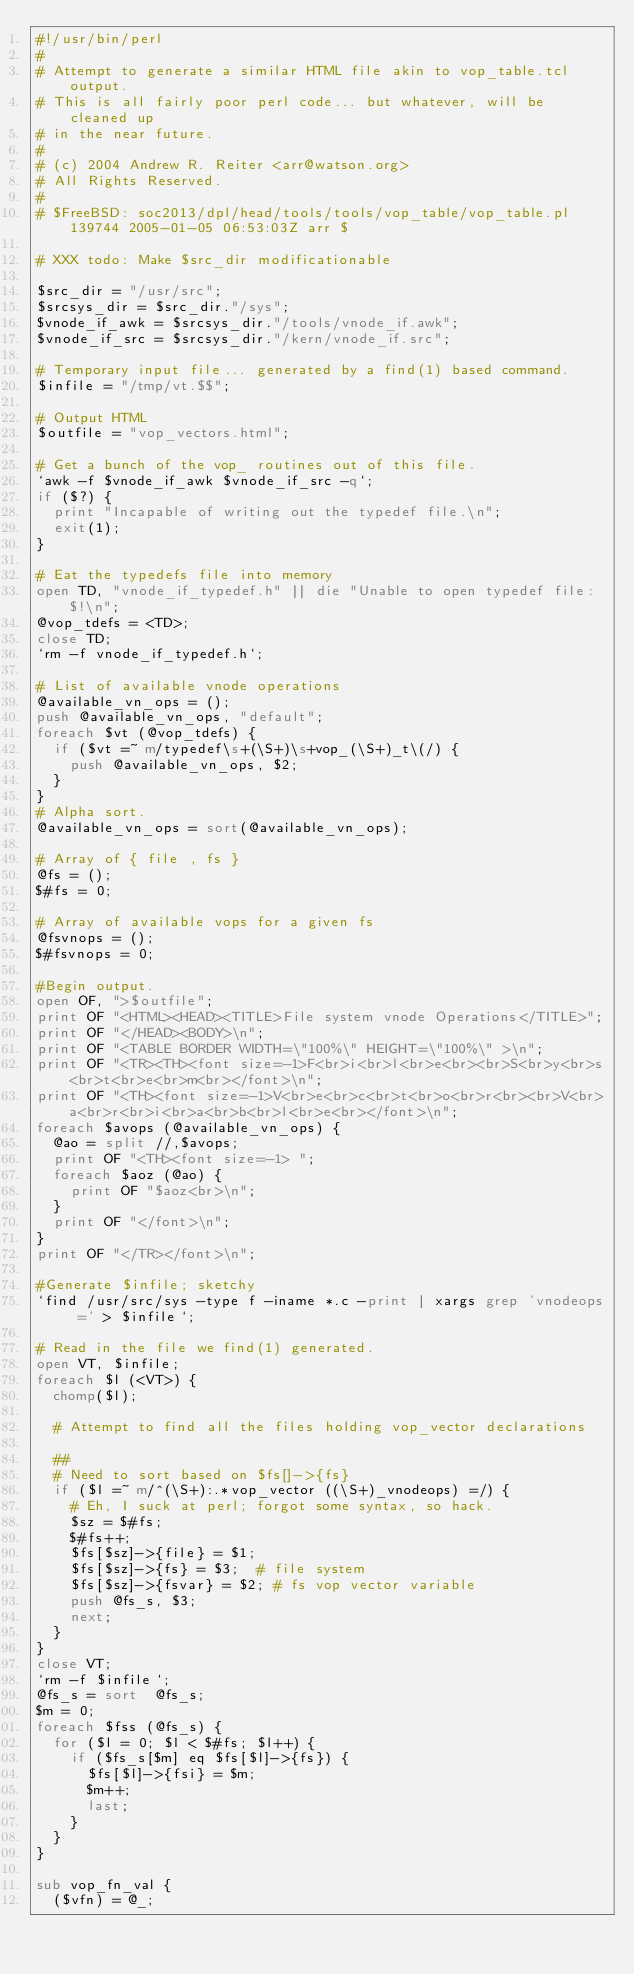<code> <loc_0><loc_0><loc_500><loc_500><_Perl_>#!/usr/bin/perl
#
# Attempt to generate a similar HTML file akin to vop_table.tcl output.
# This is all fairly poor perl code... but whatever, will be cleaned up
# in the near future.
#
# (c) 2004 Andrew R. Reiter <arr@watson.org>
# All Rights Reserved.
#
# $FreeBSD: soc2013/dpl/head/tools/tools/vop_table/vop_table.pl 139744 2005-01-05 06:53:03Z arr $

# XXX todo: Make $src_dir modificationable

$src_dir = "/usr/src";
$srcsys_dir = $src_dir."/sys";
$vnode_if_awk = $srcsys_dir."/tools/vnode_if.awk";
$vnode_if_src = $srcsys_dir."/kern/vnode_if.src";

# Temporary input file... generated by a find(1) based command.
$infile = "/tmp/vt.$$";

# Output HTML
$outfile = "vop_vectors.html";

# Get a bunch of the vop_ routines out of this file.
`awk -f $vnode_if_awk $vnode_if_src -q`;
if ($?) {
	print "Incapable of writing out the typedef file.\n";
	exit(1);
}

# Eat the typedefs file into memory 
open TD, "vnode_if_typedef.h" || die "Unable to open typedef file: $!\n";
@vop_tdefs = <TD>;
close TD;
`rm -f vnode_if_typedef.h`;

# List of available vnode operations
@available_vn_ops = ();
push @available_vn_ops, "default";
foreach $vt (@vop_tdefs) {
	if ($vt =~ m/typedef\s+(\S+)\s+vop_(\S+)_t\(/) {
		push @available_vn_ops, $2;
	}
}
# Alpha sort.
@available_vn_ops = sort(@available_vn_ops);

# Array of { file , fs }
@fs = ();
$#fs = 0;

# Array of available vops for a given fs
@fsvnops = ();
$#fsvnops = 0;

#Begin output.
open OF, ">$outfile";
print OF "<HTML><HEAD><TITLE>File system vnode Operations</TITLE>";
print OF "</HEAD><BODY>\n";
print OF "<TABLE BORDER WIDTH=\"100%\" HEIGHT=\"100%\" >\n";
print OF "<TR><TH><font size=-1>F<br>i<br>l<br>e<br><br>S<br>y<br>s<br>t<br>e<br>m<br></font>\n";
print OF "<TH><font size=-1>V<br>e<br>c<br>t<br>o<br>r<br><br>V<br>a<br>r<br>i<br>a<br>b<br>l<br>e<br></font>\n";
foreach $avops (@available_vn_ops) {
	@ao = split //,$avops;
	print OF "<TH><font size=-1> ";
	foreach $aoz (@ao) {
		print OF "$aoz<br>\n";
	}
	print OF "</font>\n";
}
print OF "</TR></font>\n";

#Generate $infile; sketchy
`find /usr/src/sys -type f -iname *.c -print | xargs grep 'vnodeops =' > $infile`;

# Read in the file we find(1) generated.
open VT, $infile;
foreach $l (<VT>) {
	chomp($l);

	# Attempt to find all the files holding vop_vector declarations
	
	##
	# Need to sort based on $fs[]->{fs}
	if ($l =~ m/^(\S+):.*vop_vector ((\S+)_vnodeops) =/) {
		# Eh, I suck at perl; forgot some syntax, so hack.
		$sz = $#fs;
		$#fs++;
		$fs[$sz]->{file} = $1;
		$fs[$sz]->{fs} = $3;	# file system 
		$fs[$sz]->{fsvar} = $2;	# fs vop vector variable
		push @fs_s, $3;
		next;
	}
}
close VT;
`rm -f $infile`;
@fs_s = sort  @fs_s;
$m = 0;
foreach $fss (@fs_s) {
	for ($l = 0; $l < $#fs; $l++) {
		if ($fs_s[$m] eq $fs[$l]->{fs}) {
			$fs[$l]->{fsi} = $m;
			$m++;
			last;
		}
	}
}

sub vop_fn_val {
	($vfn) = @_;</code> 